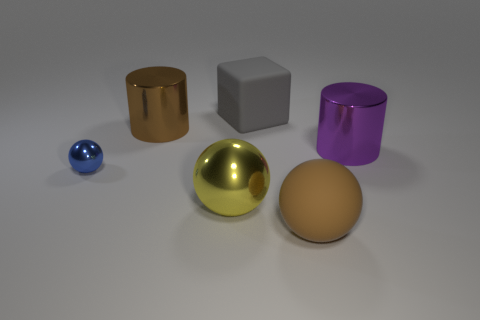What number of things are small yellow rubber cylinders or rubber things?
Offer a terse response. 2. There is a rubber thing in front of the large gray matte block; what is its size?
Keep it short and to the point. Large. What number of other things are there of the same material as the large block
Your answer should be compact. 1. Are there any metal things behind the large metallic cylinder that is in front of the brown cylinder?
Offer a terse response. Yes. Is there any other thing that has the same shape as the gray rubber object?
Your answer should be compact. No. There is a rubber thing that is the same shape as the small blue metallic thing; what is its color?
Ensure brevity in your answer.  Brown. How big is the blue sphere?
Offer a very short reply. Small. Is the number of big yellow shiny balls behind the big block less than the number of large gray rubber spheres?
Offer a terse response. No. Does the big block have the same material as the brown thing in front of the large purple metallic cylinder?
Make the answer very short. Yes. There is a big matte thing behind the big sphere to the right of the gray block; are there any blue shiny spheres that are behind it?
Your answer should be very brief. No. 